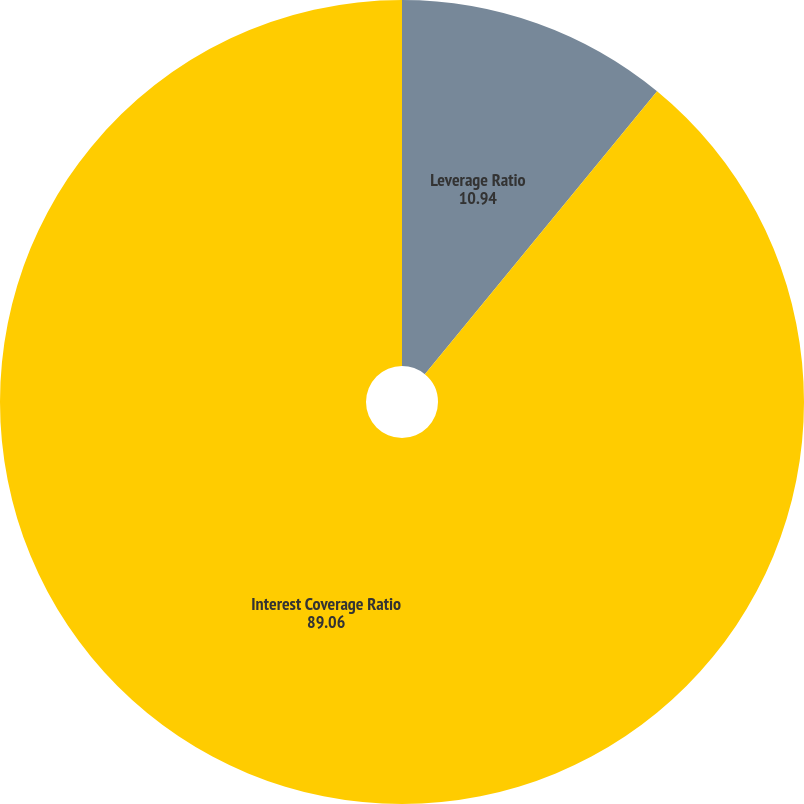<chart> <loc_0><loc_0><loc_500><loc_500><pie_chart><fcel>Leverage Ratio<fcel>Interest Coverage Ratio<nl><fcel>10.94%<fcel>89.06%<nl></chart> 